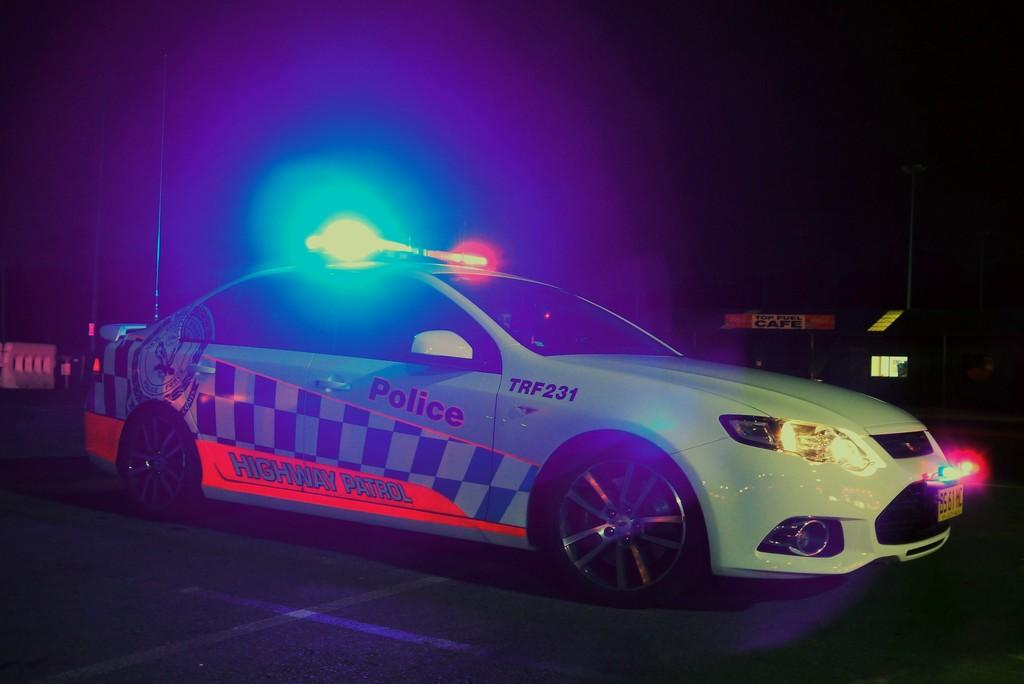What type of vehicle is in the image? There is a white color police car in the image. What features are present on the police car? The police car has lights and stickers attached to it. What is the color of the background in the image? The background of the image is black. How many snails can be seen crawling on the shelf in the image? There is no shelf or snails present in the image; it features a white color police car with lights and stickers. 